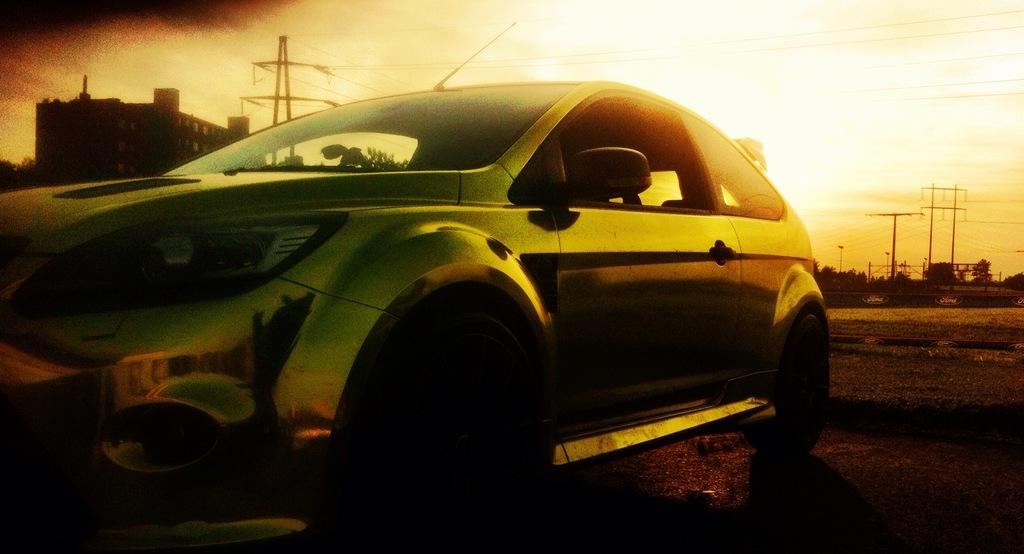What is the main subject of the image? There is a car in the image. What can be seen in the background of the image? There is a building, poles, wires, and trees in the background of the image. What type of line can be seen connecting the trees in the image? There is no line connecting the trees in the image; the trees are separate entities. Where is the camp located in the image? There is no camp present in the image. 